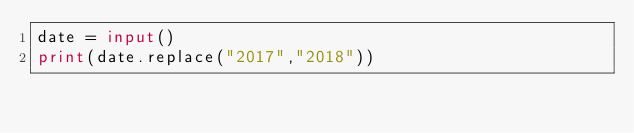Convert code to text. <code><loc_0><loc_0><loc_500><loc_500><_Python_>date = input()
print(date.replace("2017","2018"))</code> 